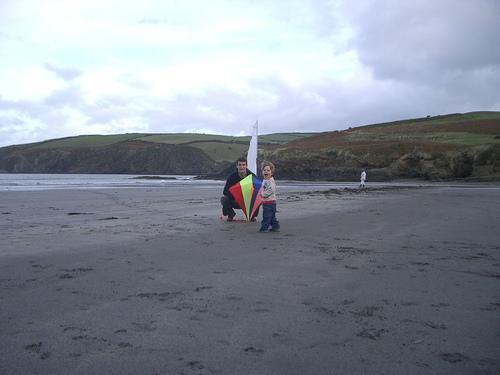How many children?
Give a very brief answer. 1. How many people do you see?
Give a very brief answer. 2. How many people are holding something?
Give a very brief answer. 2. How many bike shadows are there?
Give a very brief answer. 0. 